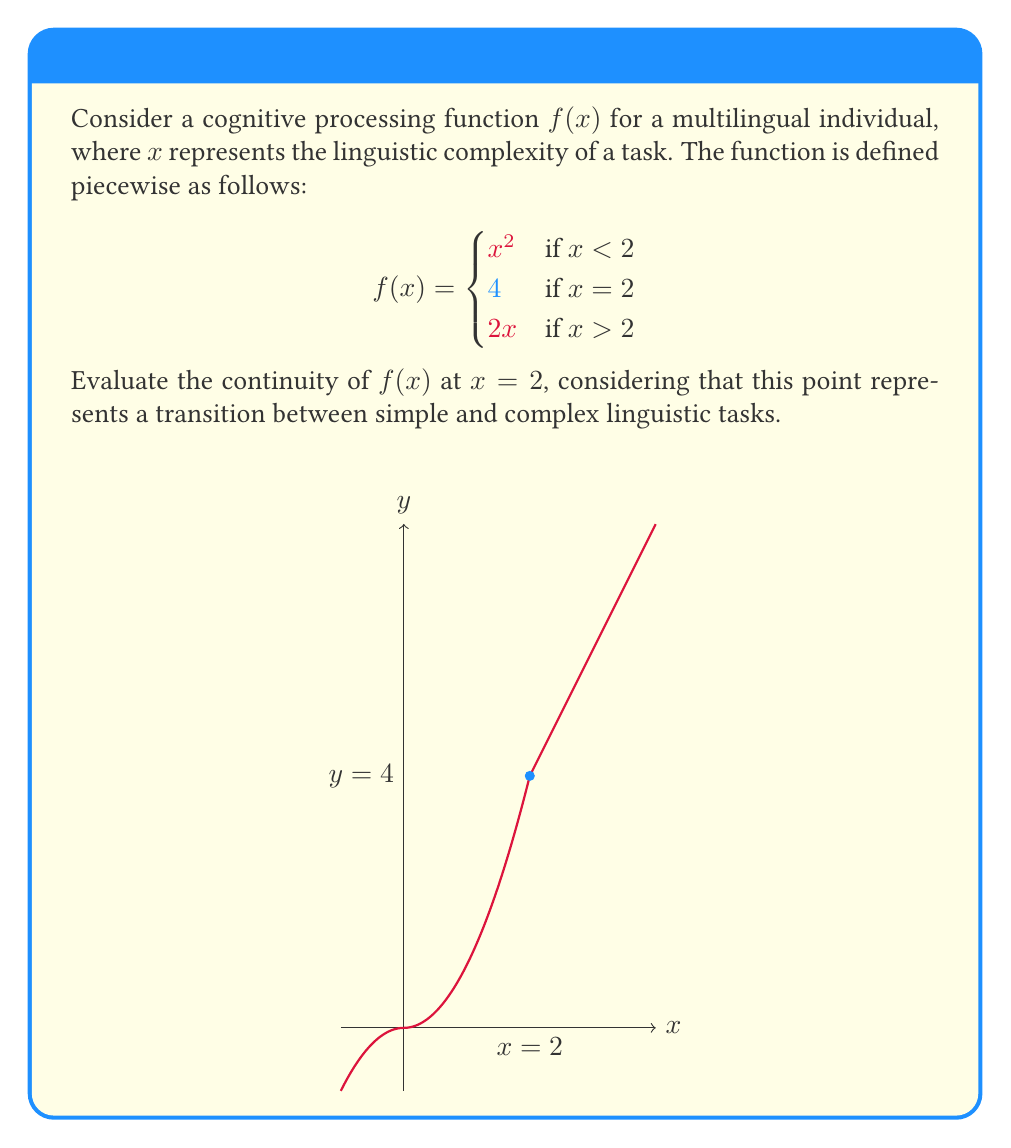Show me your answer to this math problem. To evaluate the continuity of $f(x)$ at $x = 2$, we need to check three conditions:

1. $f(2)$ must be defined.
2. $\lim_{x \to 2^-} f(x)$ must exist.
3. $\lim_{x \to 2^+} f(x)$ must exist.
4. Both limits must equal $f(2)$.

Step 1: $f(2)$ is defined and equals 4.

Step 2: Let's evaluate $\lim_{x \to 2^-} f(x)$:
$$\lim_{x \to 2^-} f(x) = \lim_{x \to 2^-} x^2 = 2^2 = 4$$

Step 3: Now, let's evaluate $\lim_{x \to 2^+} f(x)$:
$$\lim_{x \to 2^+} f(x) = \lim_{x \to 2^+} 2x = 2(2) = 4$$

Step 4: We can see that:
$$\lim_{x \to 2^-} f(x) = \lim_{x \to 2^+} f(x) = f(2) = 4$$

Therefore, all conditions for continuity are satisfied. The function $f(x)$ is continuous at $x = 2$, indicating a smooth transition in cognitive processing between simple and complex linguistic tasks for the multilingual individual.
Answer: $f(x)$ is continuous at $x = 2$ 